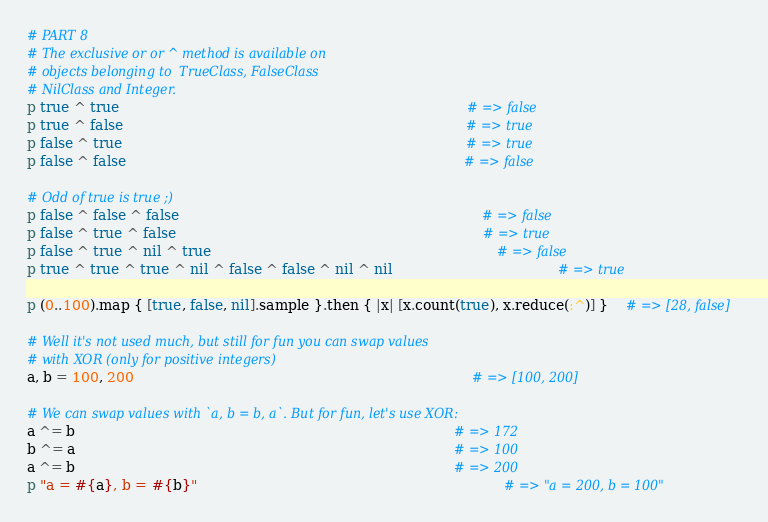<code> <loc_0><loc_0><loc_500><loc_500><_Ruby_># PART 8                                                                                   
# The exclusive or or ^ method is available on                                             
# objects belonging to  TrueClass, FalseClass                                              
# NilClass and Integer.                                                                    
p true ^ true                                                                              # => false
p true ^ false                                                                             # => true
p false ^ true                                                                             # => true
p false ^ false                                                                            # => false
                                                                                           
# Odd of true is true ;)                                                                   
p false ^ false ^ false                                                                    # => false
p false ^ true ^ false                                                                     # => true
p false ^ true ^ nil ^ true                                                                # => false
p true ^ true ^ true ^ nil ^ false ^ false ^ nil ^ nil                                     # => true
                                                                                           
p (0..100).map { [true, false, nil].sample }.then { |x| [x.count(true), x.reduce(:^)] }    # => [28, false]
                                                                                           
# Well it's not used much, but still for fun you can swap values                           
# with XOR (only for positive integers)                                                    
a, b = 100, 200                                                                            # => [100, 200]
                                                                                           
# We can swap values with `a, b = b, a`. But for fun, let's use XOR:                       
a ^= b                                                                                     # => 172
b ^= a                                                                                     # => 100
a ^= b                                                                                     # => 200
p "a = #{a}, b = #{b}"                                                                     # => "a = 200, b = 100"
</code> 